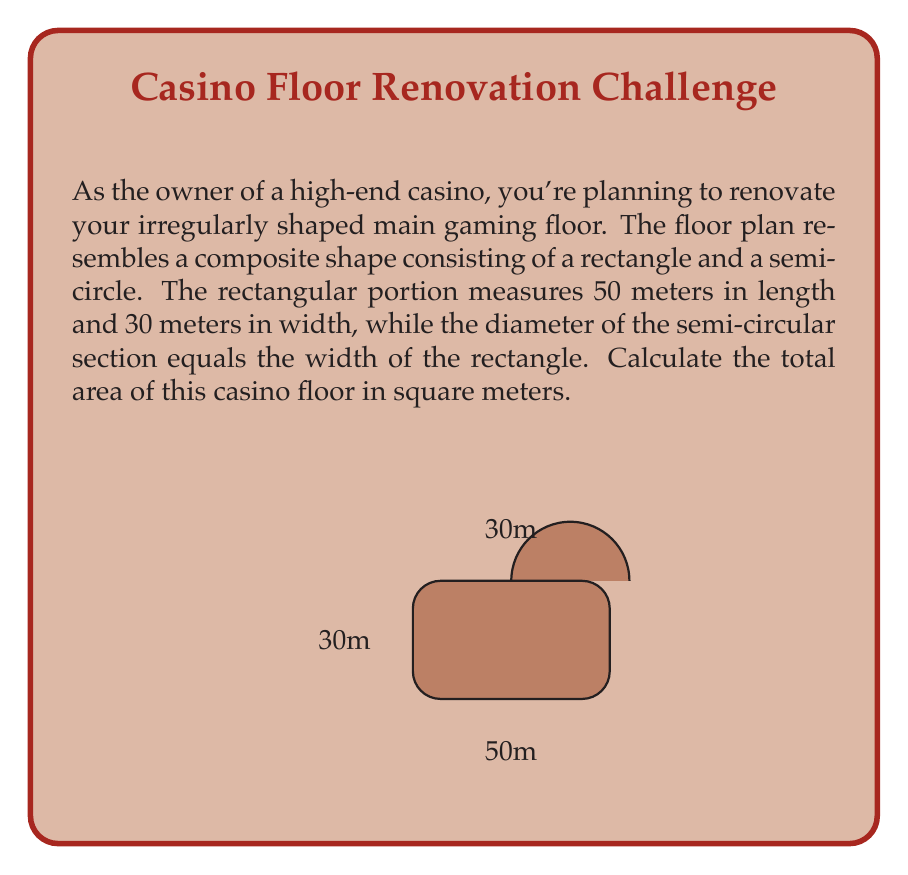Can you answer this question? To solve this problem, we need to calculate the areas of both the rectangular and semi-circular portions of the floor plan, then add them together.

1. Area of the rectangle:
   $A_{rectangle} = length \times width$
   $A_{rectangle} = 50m \times 30m = 1500m^2$

2. Area of the semi-circle:
   The diameter of the semi-circle is equal to the width of the rectangle, which is 30m.
   Therefore, the radius is half of this, 15m.
   
   Area of a full circle: $A_{circle} = \pi r^2$
   Area of a semi-circle: $A_{semi-circle} = \frac{1}{2} \pi r^2$
   
   $A_{semi-circle} = \frac{1}{2} \times \pi \times 15^2$
   $A_{semi-circle} = \frac{1}{2} \times \pi \times 225 = 353.43m^2$ (rounded to 2 decimal places)

3. Total area:
   $A_{total} = A_{rectangle} + A_{semi-circle}$
   $A_{total} = 1500m^2 + 353.43m^2 = 1853.43m^2$

Therefore, the total area of the casino floor is approximately 1853.43 square meters.
Answer: $$1853.43m^2$$ 